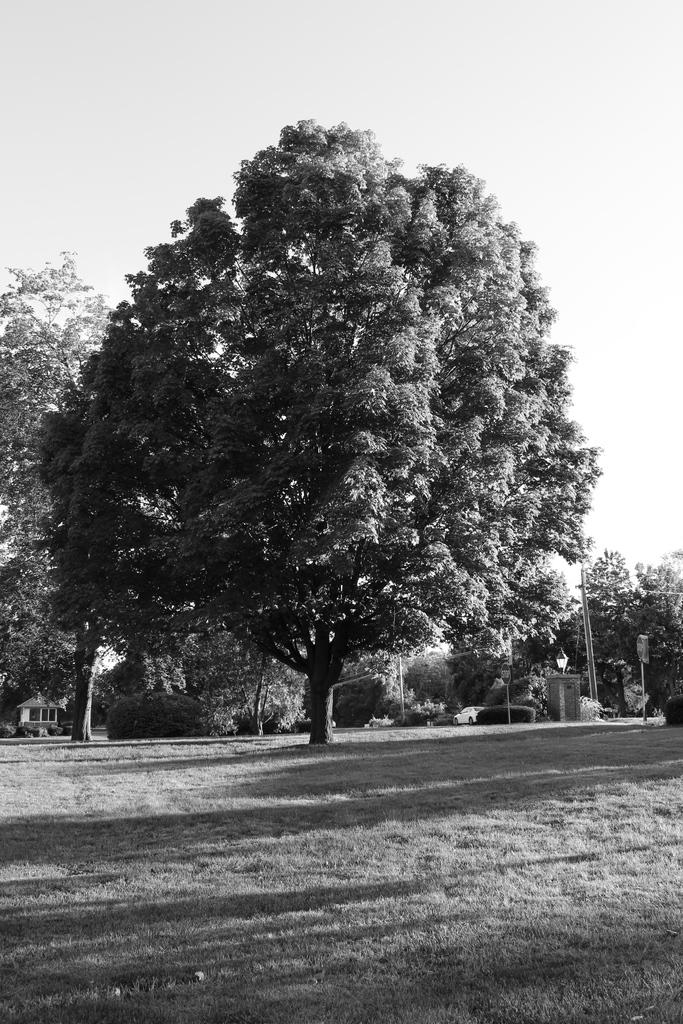What is the color scheme of the image? The image is black and white. What type of vegetation can be seen in the image? There are trees on the ground in the image. What structure is located behind the trees in the image? There is a small hut behind the trees in the image. How many pigs are seen kissing each other in the image? There are no pigs present in the image, and therefore no such activity can be observed. What type of stick is being used by the person in the image? There are no people or sticks present in the image. 